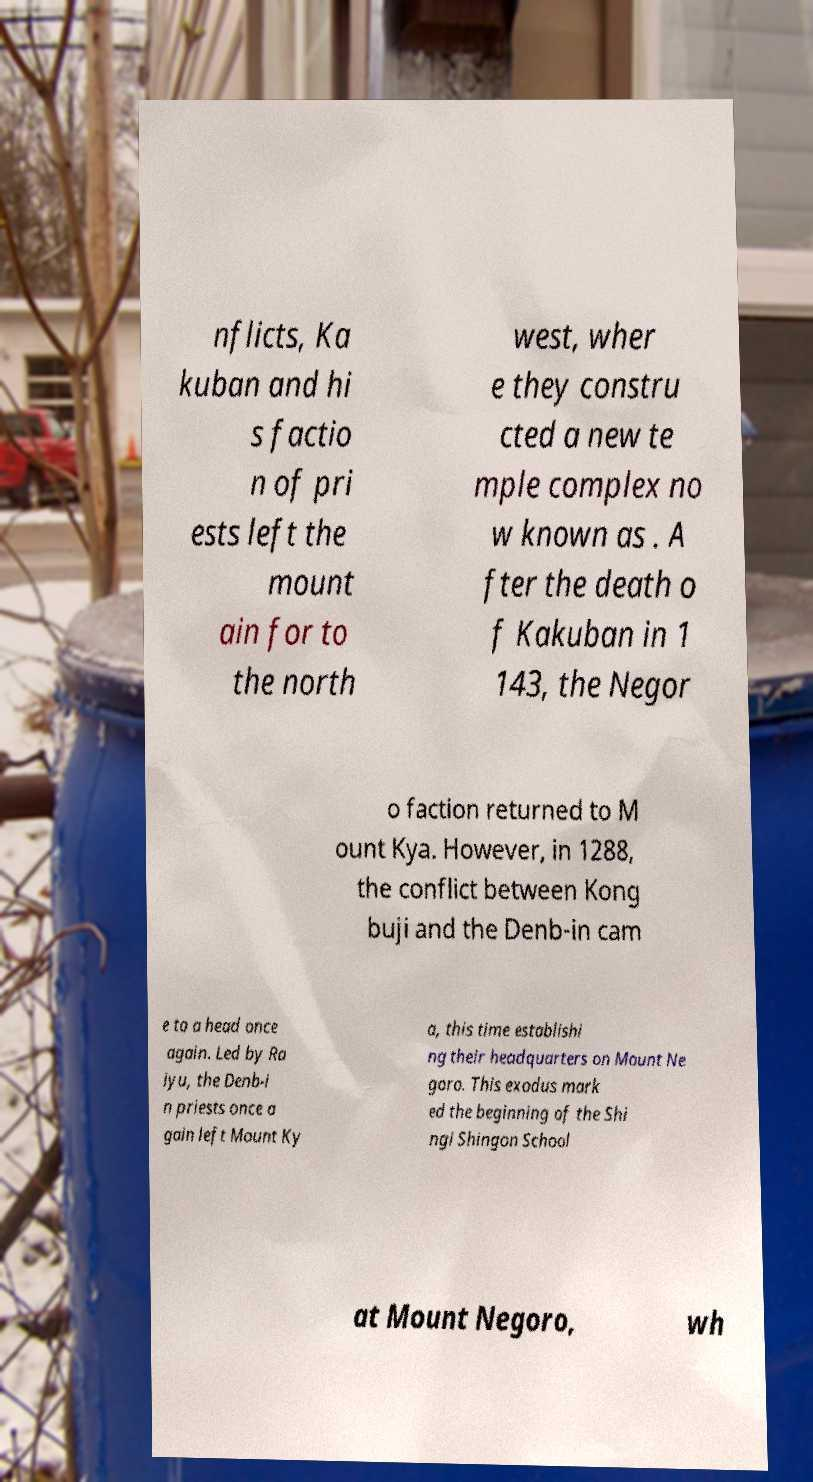There's text embedded in this image that I need extracted. Can you transcribe it verbatim? nflicts, Ka kuban and hi s factio n of pri ests left the mount ain for to the north west, wher e they constru cted a new te mple complex no w known as . A fter the death o f Kakuban in 1 143, the Negor o faction returned to M ount Kya. However, in 1288, the conflict between Kong buji and the Denb-in cam e to a head once again. Led by Ra iyu, the Denb-i n priests once a gain left Mount Ky a, this time establishi ng their headquarters on Mount Ne goro. This exodus mark ed the beginning of the Shi ngi Shingon School at Mount Negoro, wh 